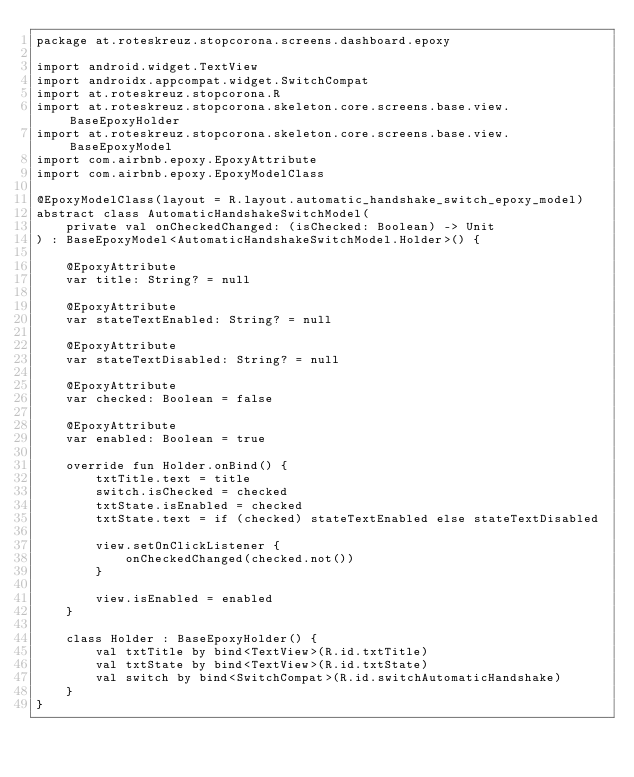Convert code to text. <code><loc_0><loc_0><loc_500><loc_500><_Kotlin_>package at.roteskreuz.stopcorona.screens.dashboard.epoxy

import android.widget.TextView
import androidx.appcompat.widget.SwitchCompat
import at.roteskreuz.stopcorona.R
import at.roteskreuz.stopcorona.skeleton.core.screens.base.view.BaseEpoxyHolder
import at.roteskreuz.stopcorona.skeleton.core.screens.base.view.BaseEpoxyModel
import com.airbnb.epoxy.EpoxyAttribute
import com.airbnb.epoxy.EpoxyModelClass

@EpoxyModelClass(layout = R.layout.automatic_handshake_switch_epoxy_model)
abstract class AutomaticHandshakeSwitchModel(
    private val onCheckedChanged: (isChecked: Boolean) -> Unit
) : BaseEpoxyModel<AutomaticHandshakeSwitchModel.Holder>() {

    @EpoxyAttribute
    var title: String? = null

    @EpoxyAttribute
    var stateTextEnabled: String? = null

    @EpoxyAttribute
    var stateTextDisabled: String? = null

    @EpoxyAttribute
    var checked: Boolean = false

    @EpoxyAttribute
    var enabled: Boolean = true

    override fun Holder.onBind() {
        txtTitle.text = title
        switch.isChecked = checked
        txtState.isEnabled = checked
        txtState.text = if (checked) stateTextEnabled else stateTextDisabled

        view.setOnClickListener {
            onCheckedChanged(checked.not())
        }

        view.isEnabled = enabled
    }

    class Holder : BaseEpoxyHolder() {
        val txtTitle by bind<TextView>(R.id.txtTitle)
        val txtState by bind<TextView>(R.id.txtState)
        val switch by bind<SwitchCompat>(R.id.switchAutomaticHandshake)
    }
}
</code> 